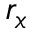Convert formula to latex. <formula><loc_0><loc_0><loc_500><loc_500>r _ { x }</formula> 